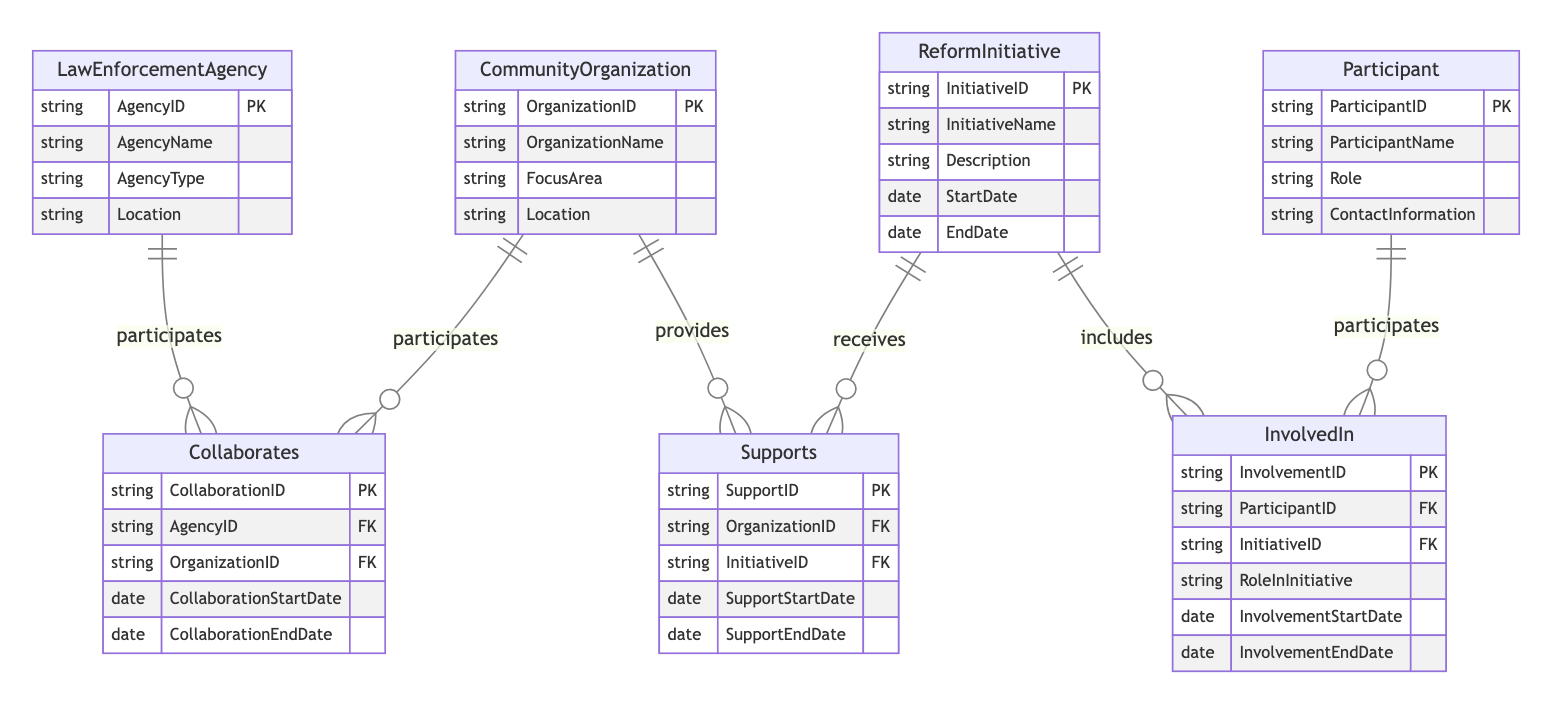What is the primary key of the Law Enforcement Agency entity? The primary key for the Law Enforcement Agency entity, as indicated in the diagram, is AgencyID.
Answer: AgencyID What is the focus area of the Community Organization entity? The focus area of the Community Organization entity is represented by the attribute FocusArea.
Answer: FocusArea How many reform initiatives can a community organization support? The diagram shows that one community organization can support multiple reform initiatives, implying a one-to-many relationship.
Answer: Many What is the name of the relationship connecting Law Enforcement Agency and Community Organization? The relationship that connects Law Enforcement Agency and Community Organization is named Collaborates.
Answer: Collaborates What attribute is used to track the start date of a reform initiative? The attribute used for tracking the start date of a reform initiative in the diagram is StartDate.
Answer: StartDate How many participants can be involved in a single reform initiative? The diagram illustrates that multiple participants can be involved in a single reform initiative, indicating a many-to-one relationship.
Answer: Many What kind of entity supports the reform initiatives according to the diagram? According to the diagram, Community Organizations support the reform initiatives.
Answer: Community Organizations Which entity contains the attribute "Contact Information"? The Participant entity contains the attribute "Contact Information."
Answer: Participant What is the main role of the Collaborates relationship? The main role of the Collaborates relationship is to depict the participation of both Law Enforcement Agencies and Community Organizations in collaborative efforts.
Answer: Participation 